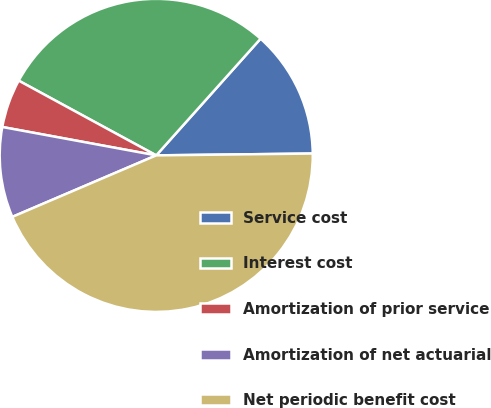Convert chart to OTSL. <chart><loc_0><loc_0><loc_500><loc_500><pie_chart><fcel>Service cost<fcel>Interest cost<fcel>Amortization of prior service<fcel>Amortization of net actuarial<fcel>Net periodic benefit cost<nl><fcel>13.2%<fcel>28.69%<fcel>5.02%<fcel>9.33%<fcel>43.76%<nl></chart> 